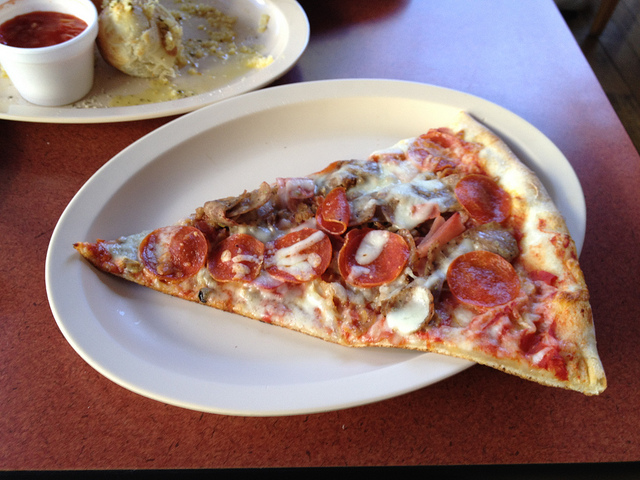Can you describe the main features of this image for me? In the manner of an art connoisseur. Behold, the depicted artifact is none other than a sumptuous slice of pizza, a culinary masterpiece casually resting on a ceramic plate of the purest white. The slice itself, a triangular canvas, displays an opulent assortment of toppings rich in color and diverse in texture. Atop the delightful golden-brown crust, one observes the vibrant pepperoni, their edges slightly curled from the heat, embracing smoky tones and deep red hues. Amidst these rounds of pepperoni, savory chunks of sausage and translucent slivers of onion contribute a complex layering of flavors. Interspersed are delicate, earth-toned mushrooms, their soft contours providing a subtle contrast to the other ingredients. This scene is complemented by a rustic wooden table which evokes a quaint charm, suggesting a relaxed dining experience. A dish of vivid red sauce in the background stands ready to add a tangy zest to the hearty ensemble. This image captures a moment of simple gastronomic joy, inviting the viewer to partake in its flavorsome abundance. 